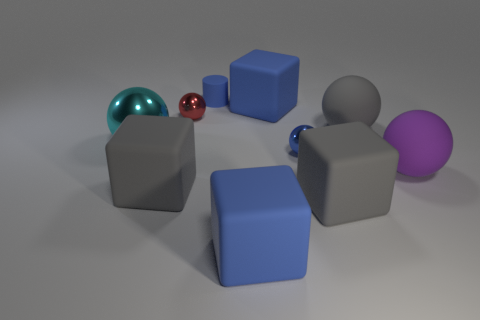What number of tiny cyan things are the same shape as the small red metal object?
Offer a terse response. 0. Do the large blue cube that is in front of the small red shiny sphere and the purple ball in front of the large metallic object have the same material?
Ensure brevity in your answer.  Yes. There is a rubber block that is behind the matte ball behind the large cyan ball; how big is it?
Provide a succinct answer. Large. There is a cyan thing that is the same shape as the red shiny object; what material is it?
Offer a terse response. Metal. Is the shape of the gray matte thing that is on the left side of the small blue metallic object the same as the cyan shiny object that is on the left side of the big purple ball?
Your answer should be very brief. No. Are there more purple cylinders than large gray rubber spheres?
Your answer should be very brief. No. How big is the red metal object?
Ensure brevity in your answer.  Small. What number of other things are the same color as the big metallic sphere?
Your response must be concise. 0. Does the big blue object in front of the purple sphere have the same material as the tiny blue cylinder?
Offer a very short reply. Yes. Is the number of big gray matte spheres to the left of the red metallic object less than the number of cylinders that are left of the large metal ball?
Offer a very short reply. No. 